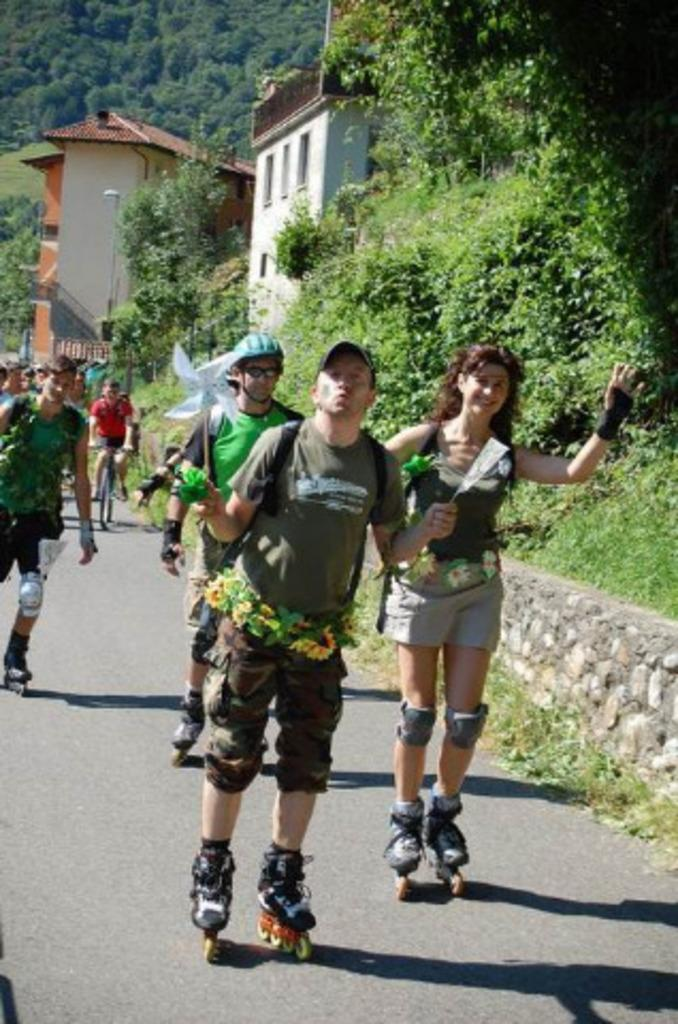What are the people in the image doing? People are standing on the road in the image. What type of shoes are the people wearing? The people are wearing skate shoes. Can you describe the activity of one person in the image? A person is riding a bicycle. What can be seen on the right side of the image? There are trees and buildings on the right side of the image. What is visible at the back of the image? There are trees at the back of the image. Reasoning: Let's think step by step by following the provided facts step by step to produce the conversation. We start by identifying the main subjects and objects in the image, which are the people and their activities. Then, we formulate questions that focus on the location and characteristics of these subjects and objects, ensuring that each question can be answered definitively with the information given. We avoid yes/no questions and ensure that the language is simple and clear. Absurd Question/Answer: What type of circle is being drawn by the person riding the bicycle in the image? There is no circle being drawn in the image; a person is simply riding a bicycle. How does the wound on the person's leg affect their ability to ride the bicycle in the image? There is no mention of a wound on anyone's leg in the image. 